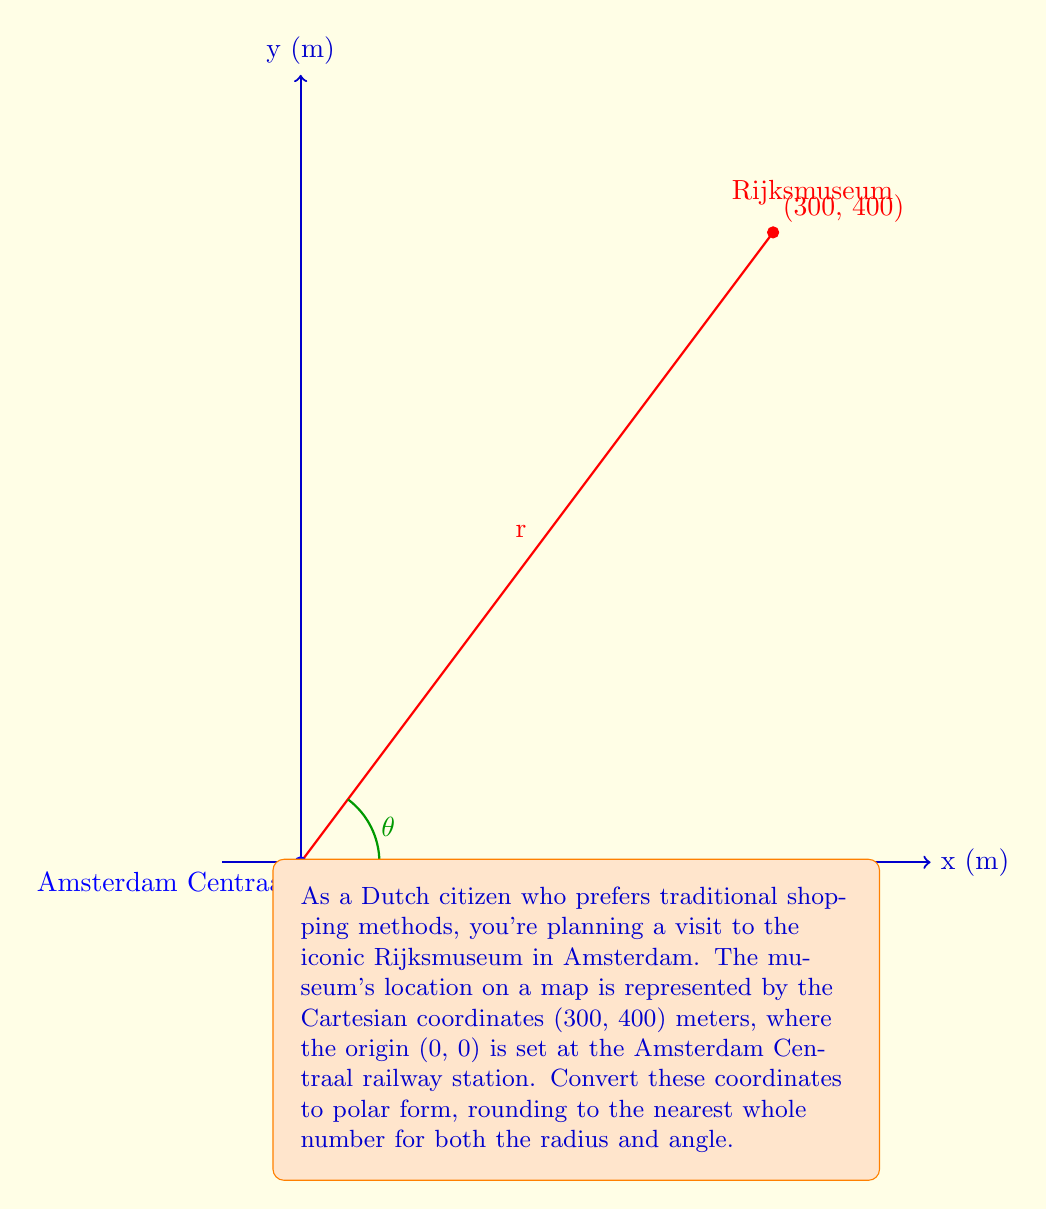Show me your answer to this math problem. To convert from Cartesian coordinates (x, y) to polar coordinates (r, θ), we use the following formulas:

1. $r = \sqrt{x^2 + y^2}$
2. $\theta = \tan^{-1}(\frac{y}{x})$

Step 1: Calculate r
$$r = \sqrt{300^2 + 400^2} = \sqrt{90,000 + 160,000} = \sqrt{250,000} = 500$$

Step 2: Calculate θ
$$\theta = \tan^{-1}(\frac{400}{300}) = \tan^{-1}(\frac{4}{3}) \approx 0.9273 \text{ radians}$$

Step 3: Convert θ to degrees
$$0.9273 \text{ radians} \times \frac{180°}{\pi} \approx 53.13°$$

Step 4: Round both values to the nearest whole number
r ≈ 500 meters
θ ≈ 53°

Therefore, the polar coordinates of the Rijksmuseum relative to Amsterdam Centraal station are approximately (500, 53°).
Answer: (500, 53°) 